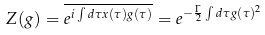Convert formula to latex. <formula><loc_0><loc_0><loc_500><loc_500>Z ( g ) = \overline { e ^ { i \int d \tau x ( \tau ) g ( \tau ) } } = e ^ { - \frac { \Gamma } { 2 } \int d \tau g ( \tau ) ^ { 2 } }</formula> 